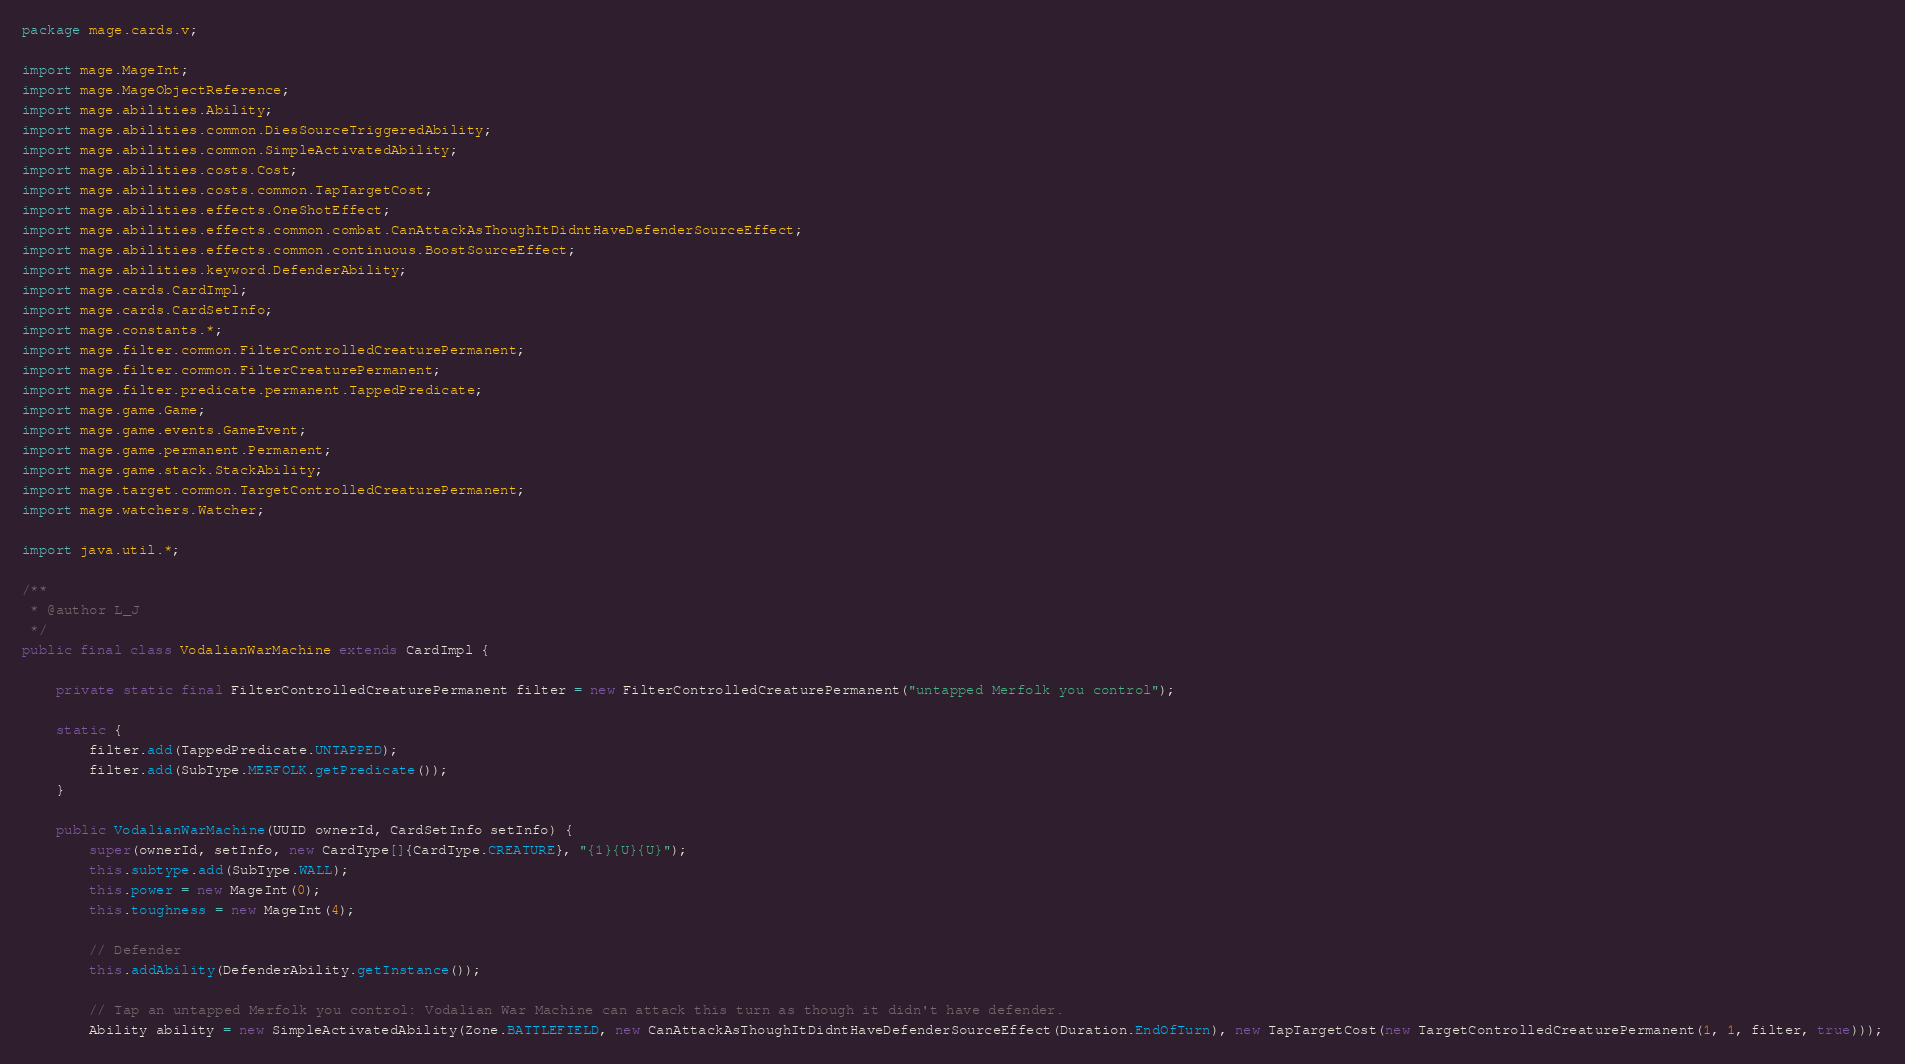<code> <loc_0><loc_0><loc_500><loc_500><_Java_>
package mage.cards.v;

import mage.MageInt;
import mage.MageObjectReference;
import mage.abilities.Ability;
import mage.abilities.common.DiesSourceTriggeredAbility;
import mage.abilities.common.SimpleActivatedAbility;
import mage.abilities.costs.Cost;
import mage.abilities.costs.common.TapTargetCost;
import mage.abilities.effects.OneShotEffect;
import mage.abilities.effects.common.combat.CanAttackAsThoughItDidntHaveDefenderSourceEffect;
import mage.abilities.effects.common.continuous.BoostSourceEffect;
import mage.abilities.keyword.DefenderAbility;
import mage.cards.CardImpl;
import mage.cards.CardSetInfo;
import mage.constants.*;
import mage.filter.common.FilterControlledCreaturePermanent;
import mage.filter.common.FilterCreaturePermanent;
import mage.filter.predicate.permanent.TappedPredicate;
import mage.game.Game;
import mage.game.events.GameEvent;
import mage.game.permanent.Permanent;
import mage.game.stack.StackAbility;
import mage.target.common.TargetControlledCreaturePermanent;
import mage.watchers.Watcher;

import java.util.*;

/**
 * @author L_J
 */
public final class VodalianWarMachine extends CardImpl {

    private static final FilterControlledCreaturePermanent filter = new FilterControlledCreaturePermanent("untapped Merfolk you control");

    static {
        filter.add(TappedPredicate.UNTAPPED);
        filter.add(SubType.MERFOLK.getPredicate());
    }

    public VodalianWarMachine(UUID ownerId, CardSetInfo setInfo) {
        super(ownerId, setInfo, new CardType[]{CardType.CREATURE}, "{1}{U}{U}");
        this.subtype.add(SubType.WALL);
        this.power = new MageInt(0);
        this.toughness = new MageInt(4);

        // Defender
        this.addAbility(DefenderAbility.getInstance());

        // Tap an untapped Merfolk you control: Vodalian War Machine can attack this turn as though it didn't have defender.
        Ability ability = new SimpleActivatedAbility(Zone.BATTLEFIELD, new CanAttackAsThoughItDidntHaveDefenderSourceEffect(Duration.EndOfTurn), new TapTargetCost(new TargetControlledCreaturePermanent(1, 1, filter, true)));</code> 